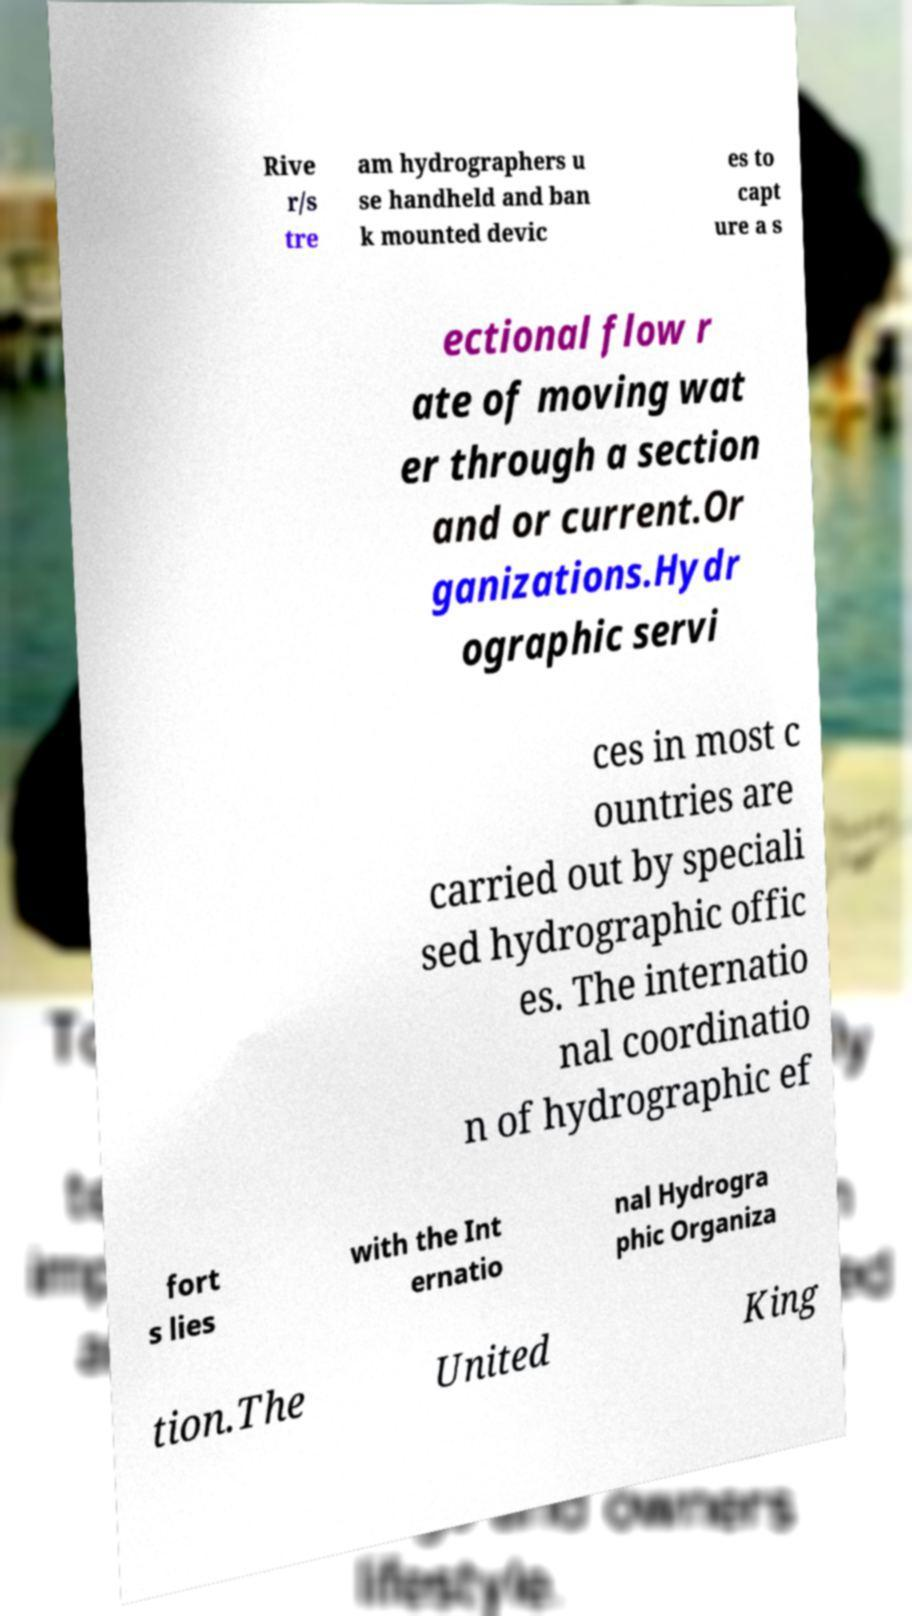Please read and relay the text visible in this image. What does it say? Rive r/s tre am hydrographers u se handheld and ban k mounted devic es to capt ure a s ectional flow r ate of moving wat er through a section and or current.Or ganizations.Hydr ographic servi ces in most c ountries are carried out by speciali sed hydrographic offic es. The internatio nal coordinatio n of hydrographic ef fort s lies with the Int ernatio nal Hydrogra phic Organiza tion.The United King 